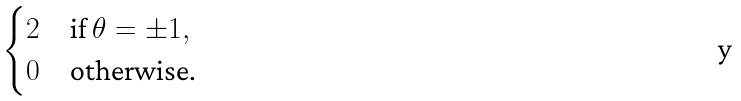Convert formula to latex. <formula><loc_0><loc_0><loc_500><loc_500>\begin{cases} 2 & \text {if } \theta = \pm 1 , \\ 0 & \text {otherwise.} \end{cases}</formula> 